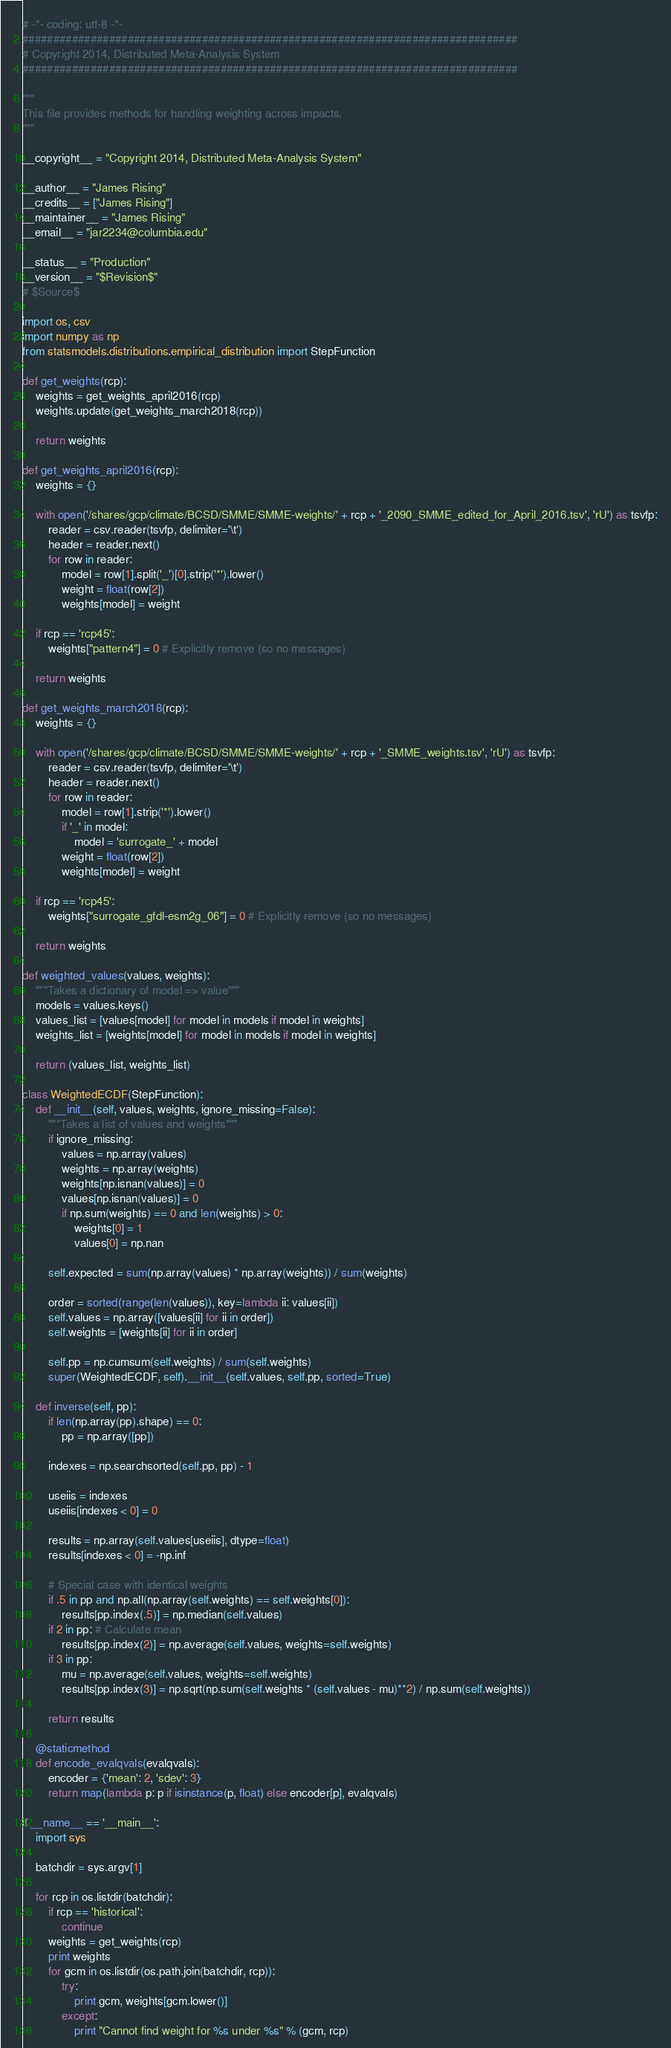Convert code to text. <code><loc_0><loc_0><loc_500><loc_500><_Python_># -*- coding: utf-8 -*-
################################################################################
# Copyright 2014, Distributed Meta-Analysis System
################################################################################

"""
This file provides methods for handling weighting across impacts.
"""

__copyright__ = "Copyright 2014, Distributed Meta-Analysis System"

__author__ = "James Rising"
__credits__ = ["James Rising"]
__maintainer__ = "James Rising"
__email__ = "jar2234@columbia.edu"

__status__ = "Production"
__version__ = "$Revision$"
# $Source$

import os, csv
import numpy as np
from statsmodels.distributions.empirical_distribution import StepFunction

def get_weights(rcp):
    weights = get_weights_april2016(rcp)
    weights.update(get_weights_march2018(rcp))

    return weights

def get_weights_april2016(rcp):
    weights = {}

    with open('/shares/gcp/climate/BCSD/SMME/SMME-weights/' + rcp + '_2090_SMME_edited_for_April_2016.tsv', 'rU') as tsvfp:
        reader = csv.reader(tsvfp, delimiter='\t')
        header = reader.next()
        for row in reader:
            model = row[1].split('_')[0].strip('*').lower()
            weight = float(row[2])
            weights[model] = weight

    if rcp == 'rcp45':
        weights["pattern4"] = 0 # Explicitly remove (so no messages)

    return weights

def get_weights_march2018(rcp):
    weights = {}

    with open('/shares/gcp/climate/BCSD/SMME/SMME-weights/' + rcp + '_SMME_weights.tsv', 'rU') as tsvfp:
        reader = csv.reader(tsvfp, delimiter='\t')
        header = reader.next()
        for row in reader:
            model = row[1].strip('*').lower()
            if '_' in model:
                model = 'surrogate_' + model
            weight = float(row[2])
            weights[model] = weight

    if rcp == 'rcp45':
        weights["surrogate_gfdl-esm2g_06"] = 0 # Explicitly remove (so no messages)
            
    return weights

def weighted_values(values, weights):
    """Takes a dictionary of model => value"""
    models = values.keys()
    values_list = [values[model] for model in models if model in weights]
    weights_list = [weights[model] for model in models if model in weights]

    return (values_list, weights_list)

class WeightedECDF(StepFunction):
    def __init__(self, values, weights, ignore_missing=False):
        """Takes a list of values and weights"""
        if ignore_missing:
            values = np.array(values)
            weights = np.array(weights)
            weights[np.isnan(values)] = 0
            values[np.isnan(values)] = 0
            if np.sum(weights) == 0 and len(weights) > 0:
                weights[0] = 1
                values[0] = np.nan
        
        self.expected = sum(np.array(values) * np.array(weights)) / sum(weights)

        order = sorted(range(len(values)), key=lambda ii: values[ii])
        self.values = np.array([values[ii] for ii in order])
        self.weights = [weights[ii] for ii in order]

        self.pp = np.cumsum(self.weights) / sum(self.weights)
        super(WeightedECDF, self).__init__(self.values, self.pp, sorted=True)

    def inverse(self, pp):
        if len(np.array(pp).shape) == 0:
            pp = np.array([pp])

        indexes = np.searchsorted(self.pp, pp) - 1

        useiis = indexes
        useiis[indexes < 0] = 0

        results = np.array(self.values[useiis], dtype=float)
        results[indexes < 0] = -np.inf

        # Special case with identical weights
        if .5 in pp and np.all(np.array(self.weights) == self.weights[0]):
            results[pp.index(.5)] = np.median(self.values)
        if 2 in pp: # Calculate mean
            results[pp.index(2)] = np.average(self.values, weights=self.weights)
        if 3 in pp:
            mu = np.average(self.values, weights=self.weights)
            results[pp.index(3)] = np.sqrt(np.sum(self.weights * (self.values - mu)**2) / np.sum(self.weights))

        return results

    @staticmethod
    def encode_evalqvals(evalqvals):
        encoder = {'mean': 2, 'sdev': 3}
        return map(lambda p: p if isinstance(p, float) else encoder[p], evalqvals)

if __name__ == '__main__':
    import sys
    
    batchdir = sys.argv[1]

    for rcp in os.listdir(batchdir):
        if rcp == 'historical':
            continue
        weights = get_weights(rcp)
        print weights
        for gcm in os.listdir(os.path.join(batchdir, rcp)):
            try:
                print gcm, weights[gcm.lower()]
            except:
                print "Cannot find weight for %s under %s" % (gcm, rcp)
</code> 